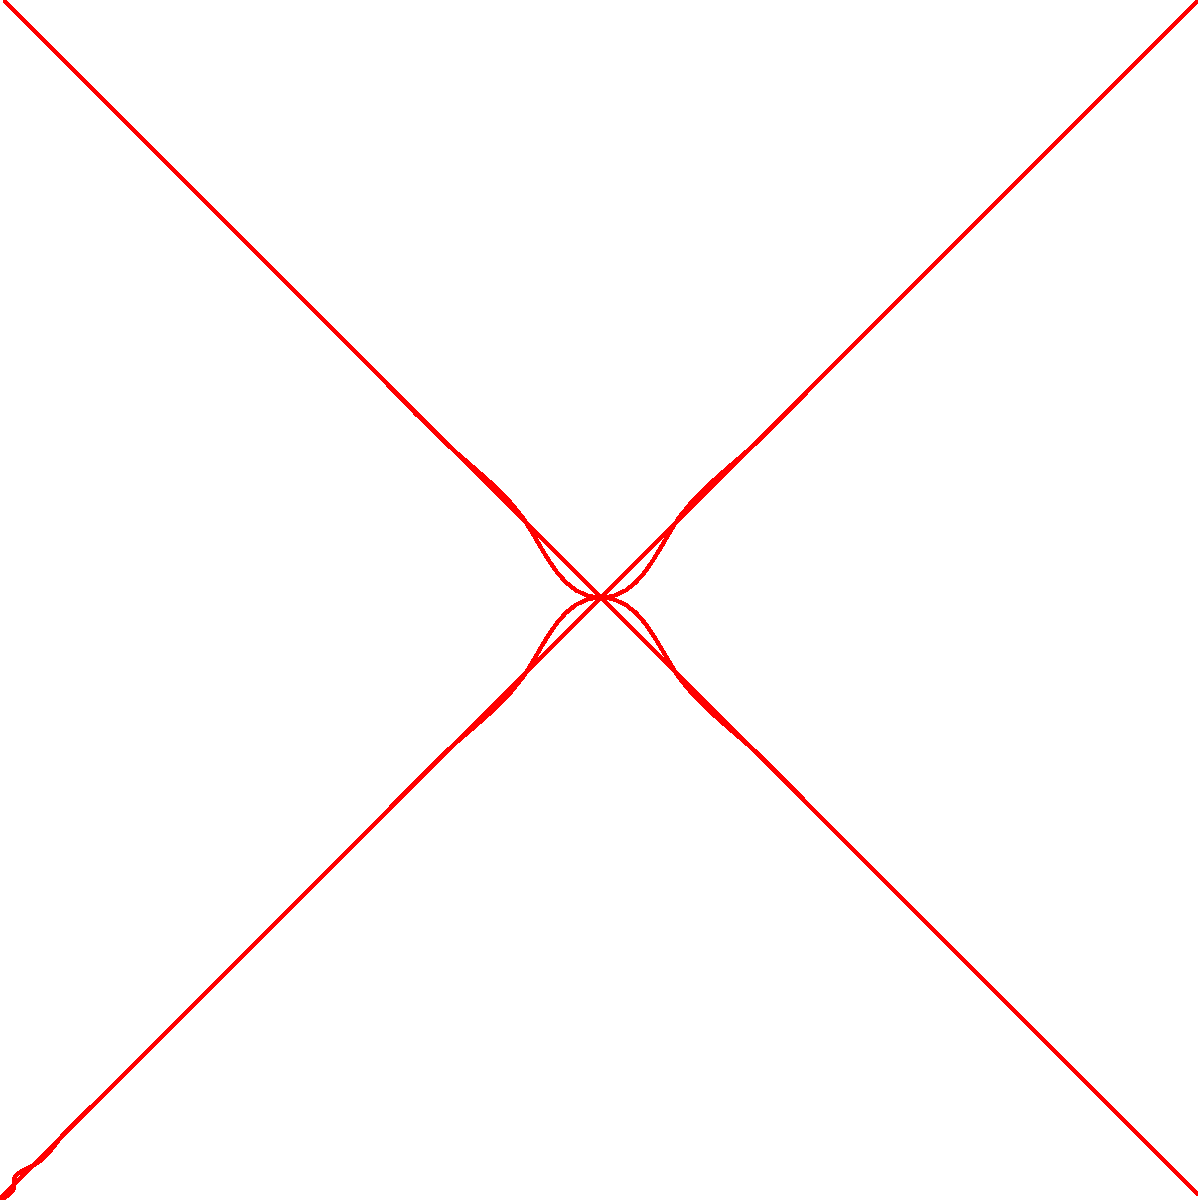Consider the heart-shaped graph representing unspoken love. If this graph is rotated 180° around the origin O, what type of symmetry does it exhibit, and how does this relate to the nature of unexpressed emotions? To answer this question, let's analyze the heart-shaped graph step by step:

1. Observe the solid red curve, which represents the original heart shape.

2. Notice the dashed red curve, which is the reflection of the original curve across the x-axis.

3. If we rotate the entire graph 180° around the origin O, the solid curve would overlap perfectly with the dashed curve, and vice versa.

4. This perfect overlap after a 180° rotation indicates that the graph has rotational symmetry of order 2.

5. In group theory, this symmetry is represented by the cyclic group $C_2$.

6. The rotational symmetry of the heart graph can be interpreted as a metaphor for the duality of unexpressed emotions:
   - The visible (solid) part represents the surface of unspoken love.
   - The hidden (dashed) part symbolizes the deeper, unexpressed feelings.
   - The 180° rotation bringing them into alignment suggests that these two aspects are intrinsically connected and complementary.

7. The origin O, being the center of rotation, can be seen as the core of these emotions, around which the expressed and unexpressed feelings revolve.

This symmetry reflects the idea that unexpressed emotions have a hidden counterpart, equally strong but often unseen, much like the dashed part of the heart in the graph.
Answer: $C_2$ rotational symmetry 